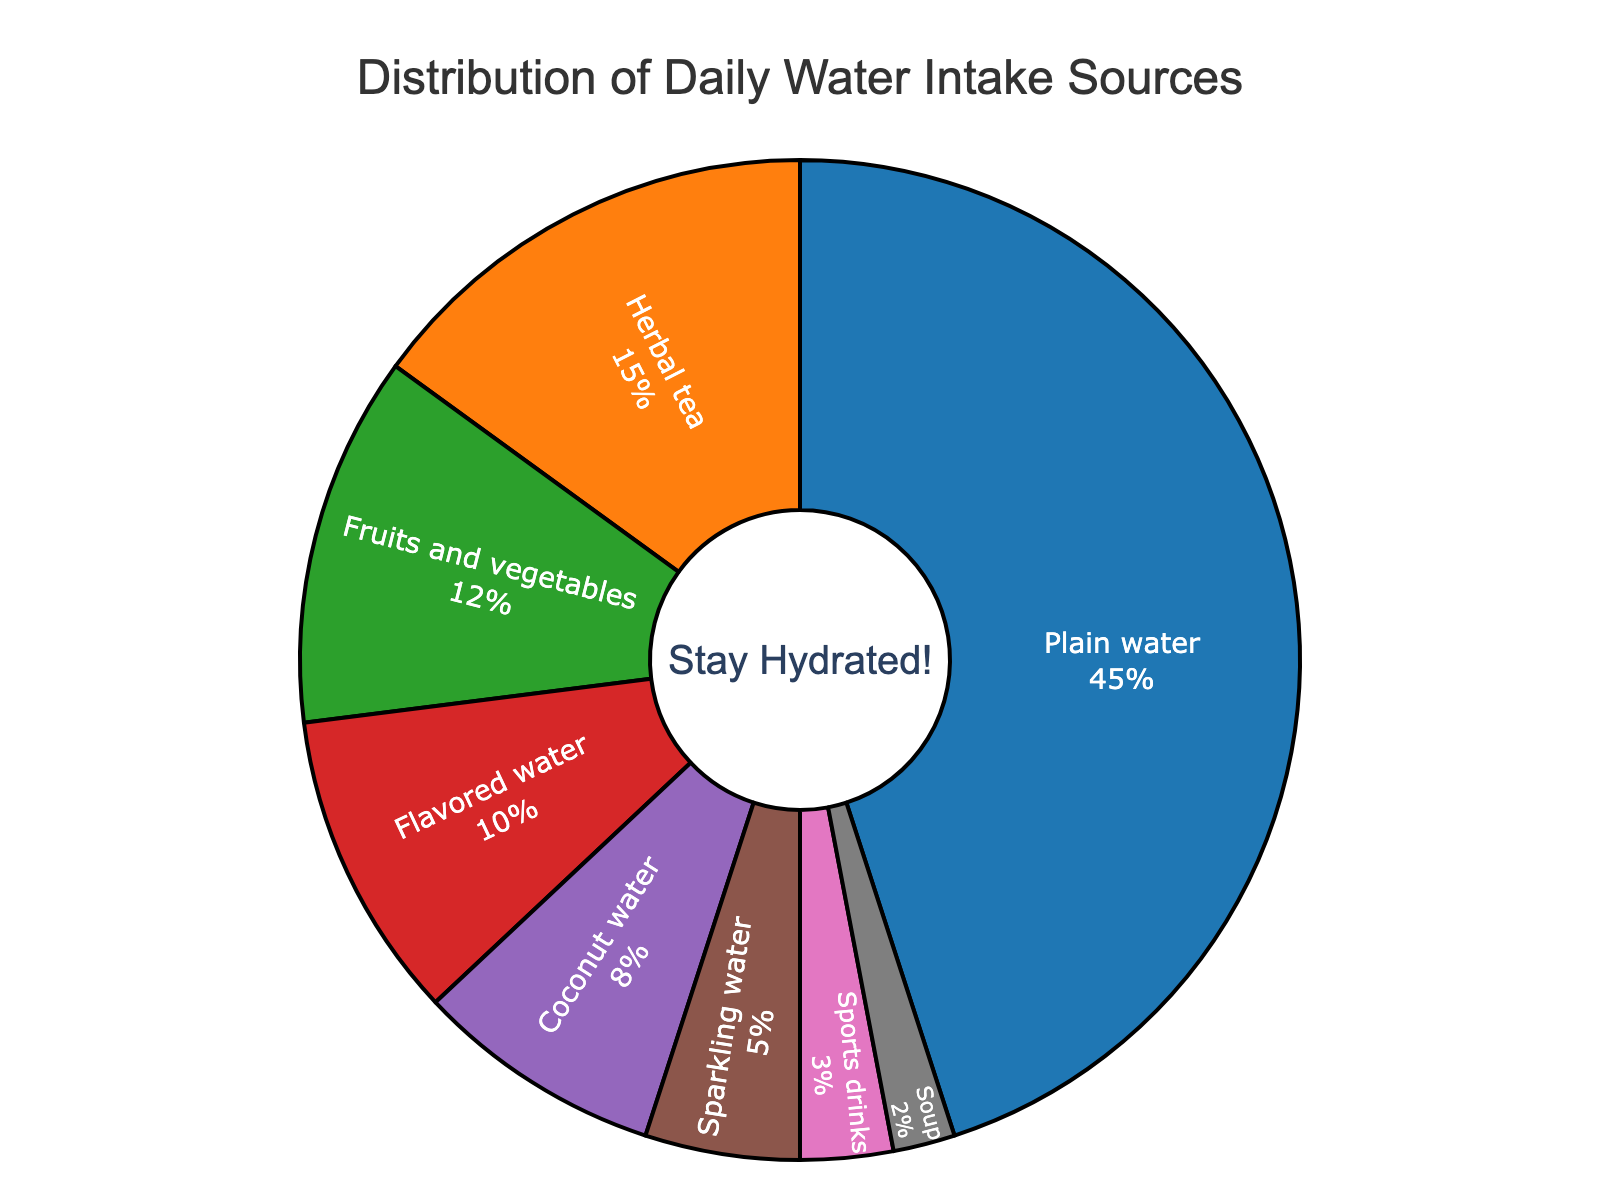What's the largest source of daily water intake? The pie chart shows various sources of daily water intake with percentages. The segment marked as "Plain water" occupies the largest area of the pie chart, indicating it is the largest source.
Answer: Plain water What's the combined percentage of coconut water and sports drinks? To find the combined percentage, add the percentage values of coconut water (8%) and sports drinks (3%) from the chart. 8% + 3% = 11%
Answer: 11% Which is more, the percentage from fruits and vegetables or sparkling water? By comparing the size of the segments, fruits and vegetables (12%) have a higher percentage than sparkling water (5%).
Answer: Fruits and vegetables How much more is the percentage of plain water compared to soup? Subtract the percentage of soup (2%) from the percentage of plain water (45%). 45% - 2% = 43%
Answer: 43% What source corresponds to the orange-colored segment? The orange-colored segment in the pie chart represents "Herbal tea."
Answer: Herbal tea What's the combined percentage of all sources except plain water? To find this, subtract the percentage of plain water (45%) from the total, 100%. 100% - 45% = 55%. Alternatively, add the percentages of all other sources.
Answer: 55% What's the difference in percentage between the two smallest sources? The two smallest sources are sports drinks (3%) and soup (2%). Subtract the smaller percentage from the larger one. 3% - 2% = 1%
Answer: 1% Is the percentage of herbal tea more than double that of flavored water? To determine this, compare twice the percentage of flavored water (10% * 2 = 20%) with the percentage of herbal tea (15%). 15% is less than 20%, so it's not more than double.
Answer: No Which source has a segment in green color? The green-colored segment represents "Fruits and vegetables" in the pie chart.
Answer: Fruits and vegetables 